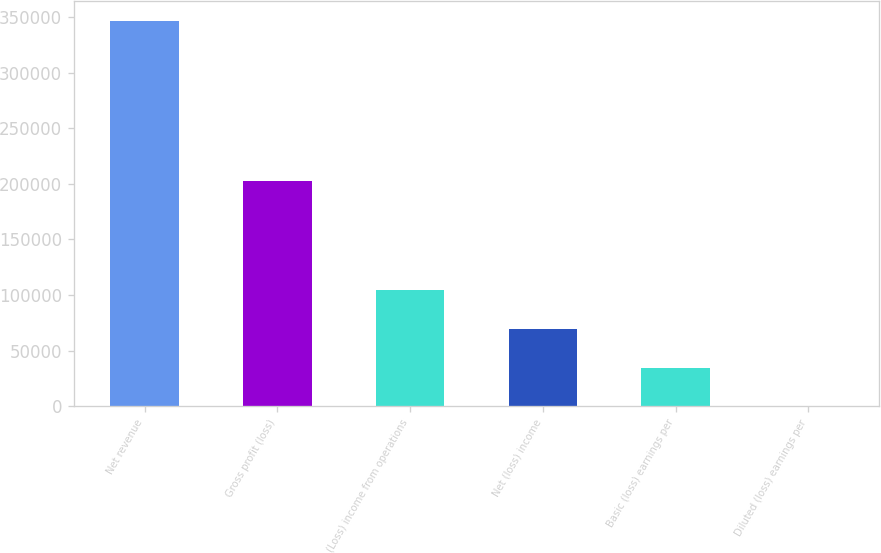<chart> <loc_0><loc_0><loc_500><loc_500><bar_chart><fcel>Net revenue<fcel>Gross profit (loss)<fcel>(Loss) income from operations<fcel>Net (loss) income<fcel>Basic (loss) earnings per<fcel>Diluted (loss) earnings per<nl><fcel>346974<fcel>203034<fcel>104093<fcel>69395.2<fcel>34697.9<fcel>0.55<nl></chart> 